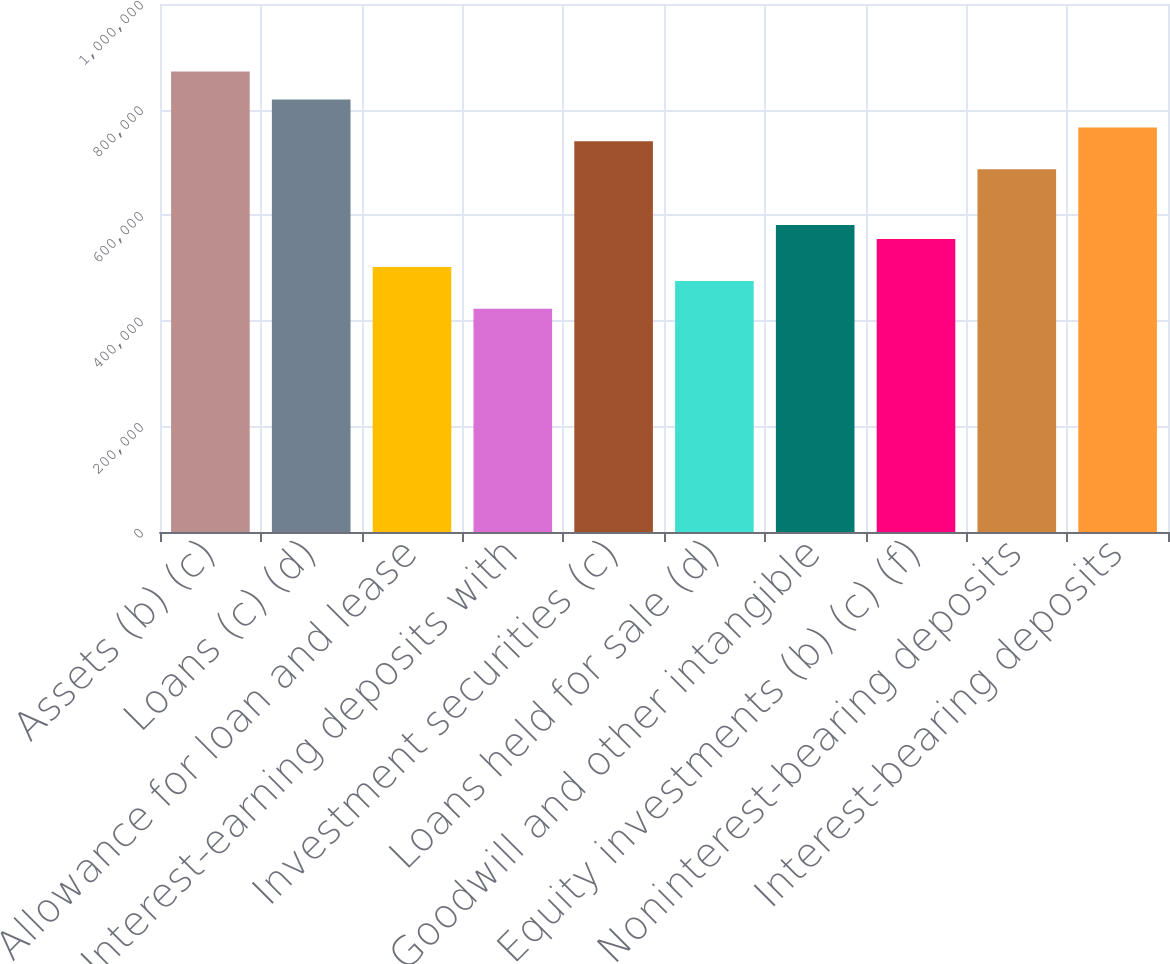Convert chart. <chart><loc_0><loc_0><loc_500><loc_500><bar_chart><fcel>Assets (b) (c)<fcel>Loans (c) (d)<fcel>Allowance for loan and lease<fcel>Interest-earning deposits with<fcel>Investment securities (c)<fcel>Loans held for sale (d)<fcel>Goodwill and other intangible<fcel>Equity investments (b) (c) (f)<fcel>Noninterest-bearing deposits<fcel>Interest-bearing deposits<nl><fcel>871956<fcel>819110<fcel>502036<fcel>422767<fcel>739842<fcel>475613<fcel>581304<fcel>554882<fcel>686996<fcel>766265<nl></chart> 